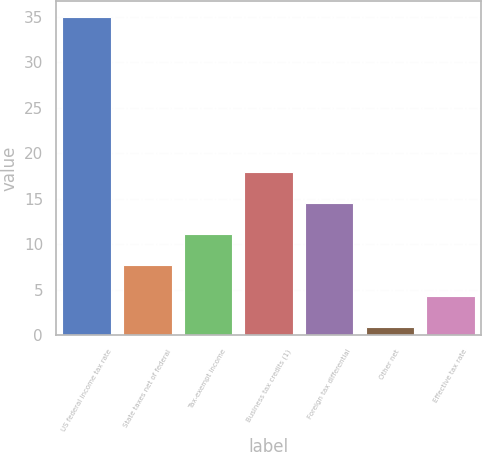Convert chart to OTSL. <chart><loc_0><loc_0><loc_500><loc_500><bar_chart><fcel>US federal income tax rate<fcel>State taxes net of federal<fcel>Tax-exempt income<fcel>Business tax credits (1)<fcel>Foreign tax differential<fcel>Other net<fcel>Effective tax rate<nl><fcel>35<fcel>7.72<fcel>11.13<fcel>17.95<fcel>14.54<fcel>0.9<fcel>4.31<nl></chart> 